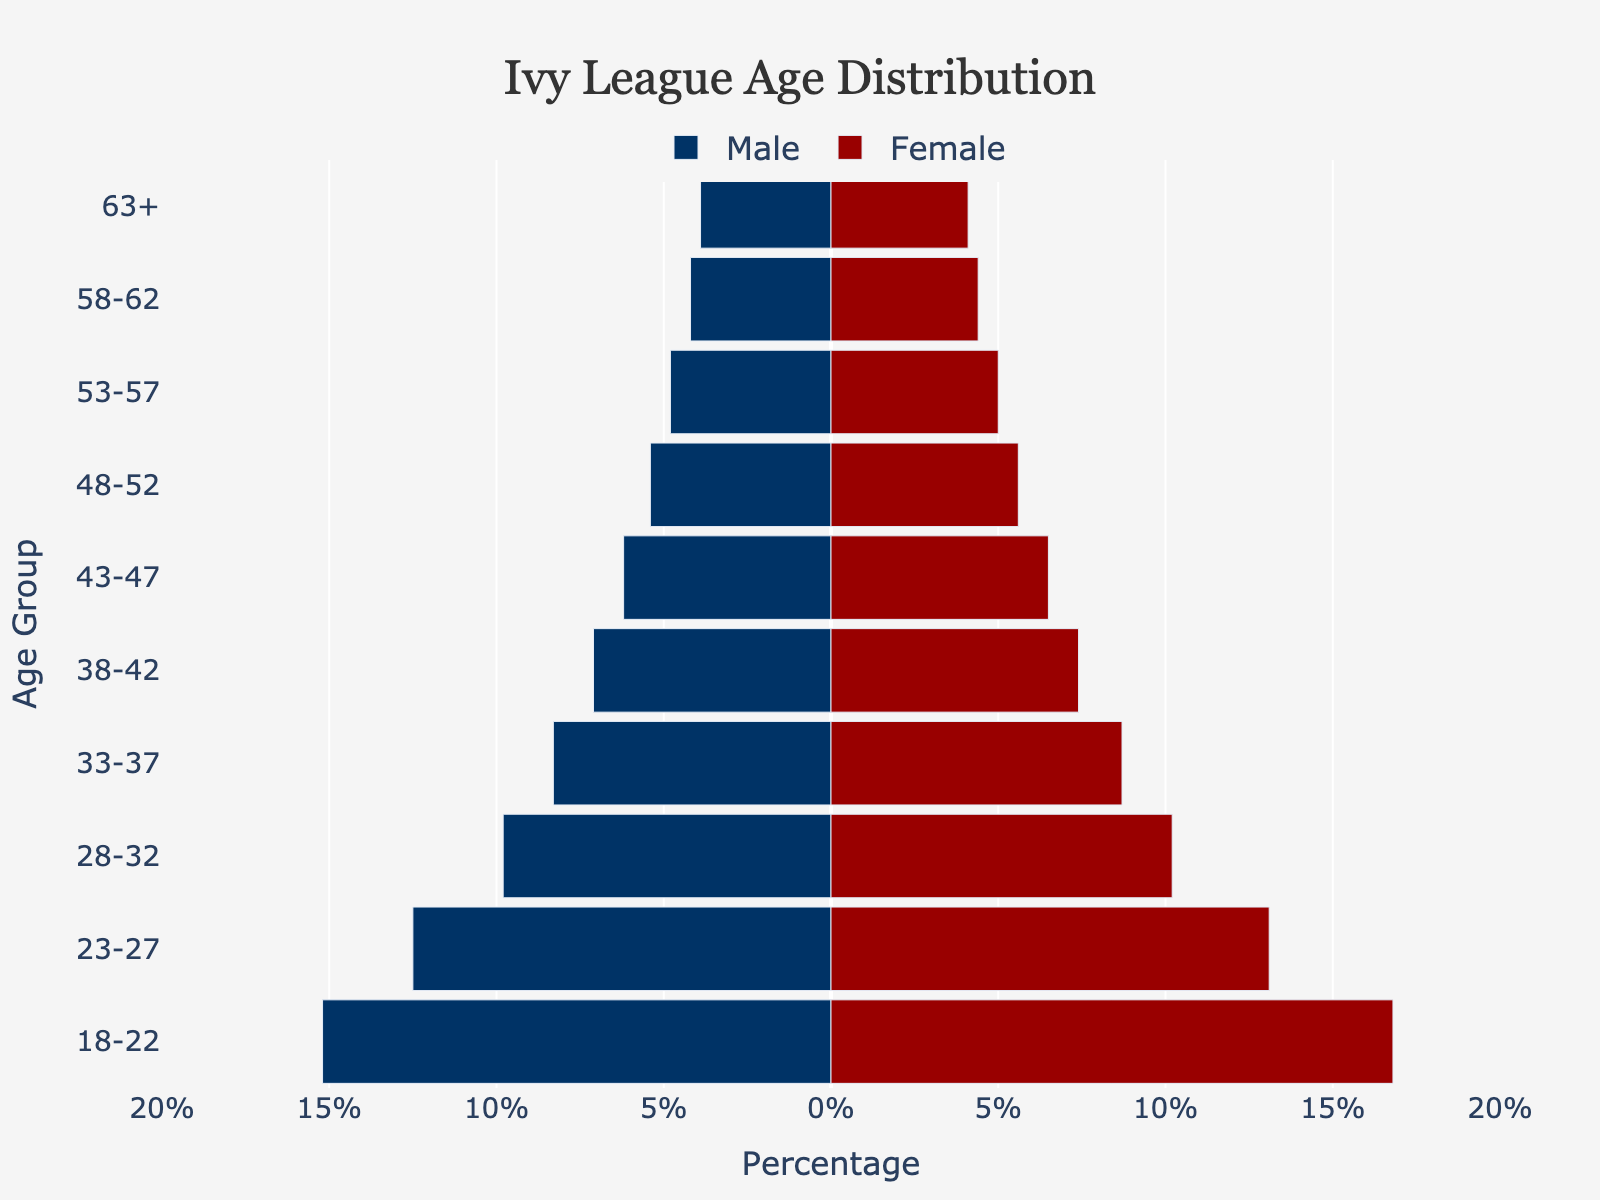How many age groups are represented in the population pyramid? The figure displays the age distribution for different age groups. By counting the distinct age group labels on the y-axis, you can determine the number of age groups represented.
Answer: 10 What is the title of the figure? The title is usually displayed at the top center of the figure. It provides a brief description of the data being presented.
Answer: Ivy League Age Distribution What percentage of males are in the 18-22 age group? Look at the population pyramid's bar section for the 18-22 age group on the left (male) side. The bar will indicate the percentage.
Answer: 15.2% Is there a gap in the age distribution bars between male and female at any age group? Inspect the bars for each age group on both sides (male and female). If there is a noticeable gap with no bars in a specific age group for either gender, then a gap is present.
Answer: No Which age group has the highest percentage of females? Compare the length of the female bars for each age group and identify the longest one.
Answer: 18-22 By how much percentage does the 23-27 female group exceed the 28-32 female group? Subtract the percentage of the 28-32 female group from the percentage of the 23-27 female group. Explanation: 13.1% (23-27 females) - 10.2% (28-32 females) = 2.9%
Answer: 2.9% What are the three oldest age groups shown in the pyramid? Identify the three highest age groups listed on the y-axis. These are the groups towards the top of the pyramid.
Answer: 48-52, 53-57, 63+ Does the percentage of males or females decrease more quickly as the age groups increase? Observe the trend in bar lengths as you move from lower to higher age groups for both males and females. Determine which gender shows a quicker reduction in bar lengths.
Answer: Males How does the population of alumni (above 30 years old) compare between males and females? Sum the percentages of the age groups above 30 years for both males and females, and compare the totals. Explanation: Males: 9.8 + 8.3 + 7.1 + 6.2 + 5.4 + 4.8 + 4.2 + 3.9 = 49.7, Females: 10.2 + 8.7 + 7.4 + 6.5 + 5.6 + 5.0 + 4.4 + 4.1 = 51.9
Answer: Females have a slightly higher population Which age group has the smallest percentage difference between males and females? For each age group, compute the absolute difference between male and female percentages. Identify the age group with the smallest difference. Explanation: Differences: (18-22:1.6, 23-27:0.6, 28-32:0.4, 33-37:0.4, 38-42:0.3, 43-47:0.3, 48-52:0.2, 53-57:0.2, 58-62:0.2, 63+:0.2)
Answer: 48-52, 53-57, 58-62, 63+ 